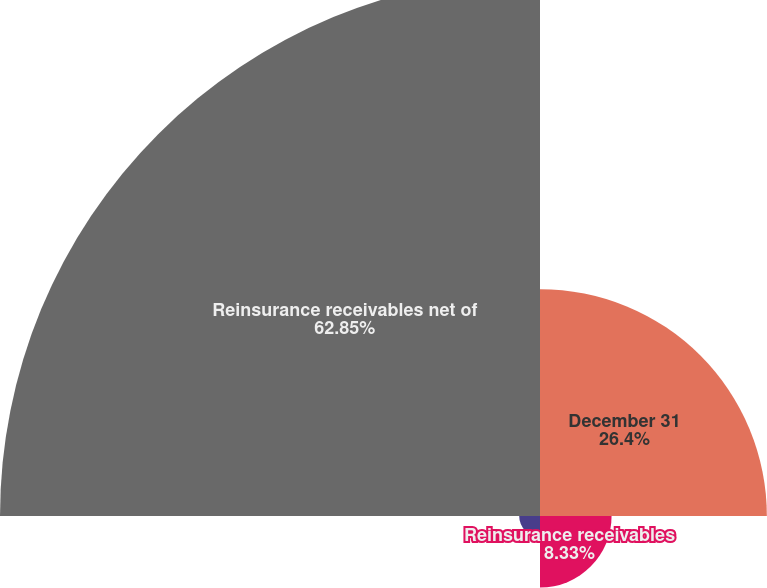<chart> <loc_0><loc_0><loc_500><loc_500><pie_chart><fcel>December 31<fcel>Reinsurance receivables<fcel>Ceded future policy benefits<fcel>Reinsurance receivables net of<nl><fcel>26.4%<fcel>8.33%<fcel>2.42%<fcel>62.84%<nl></chart> 